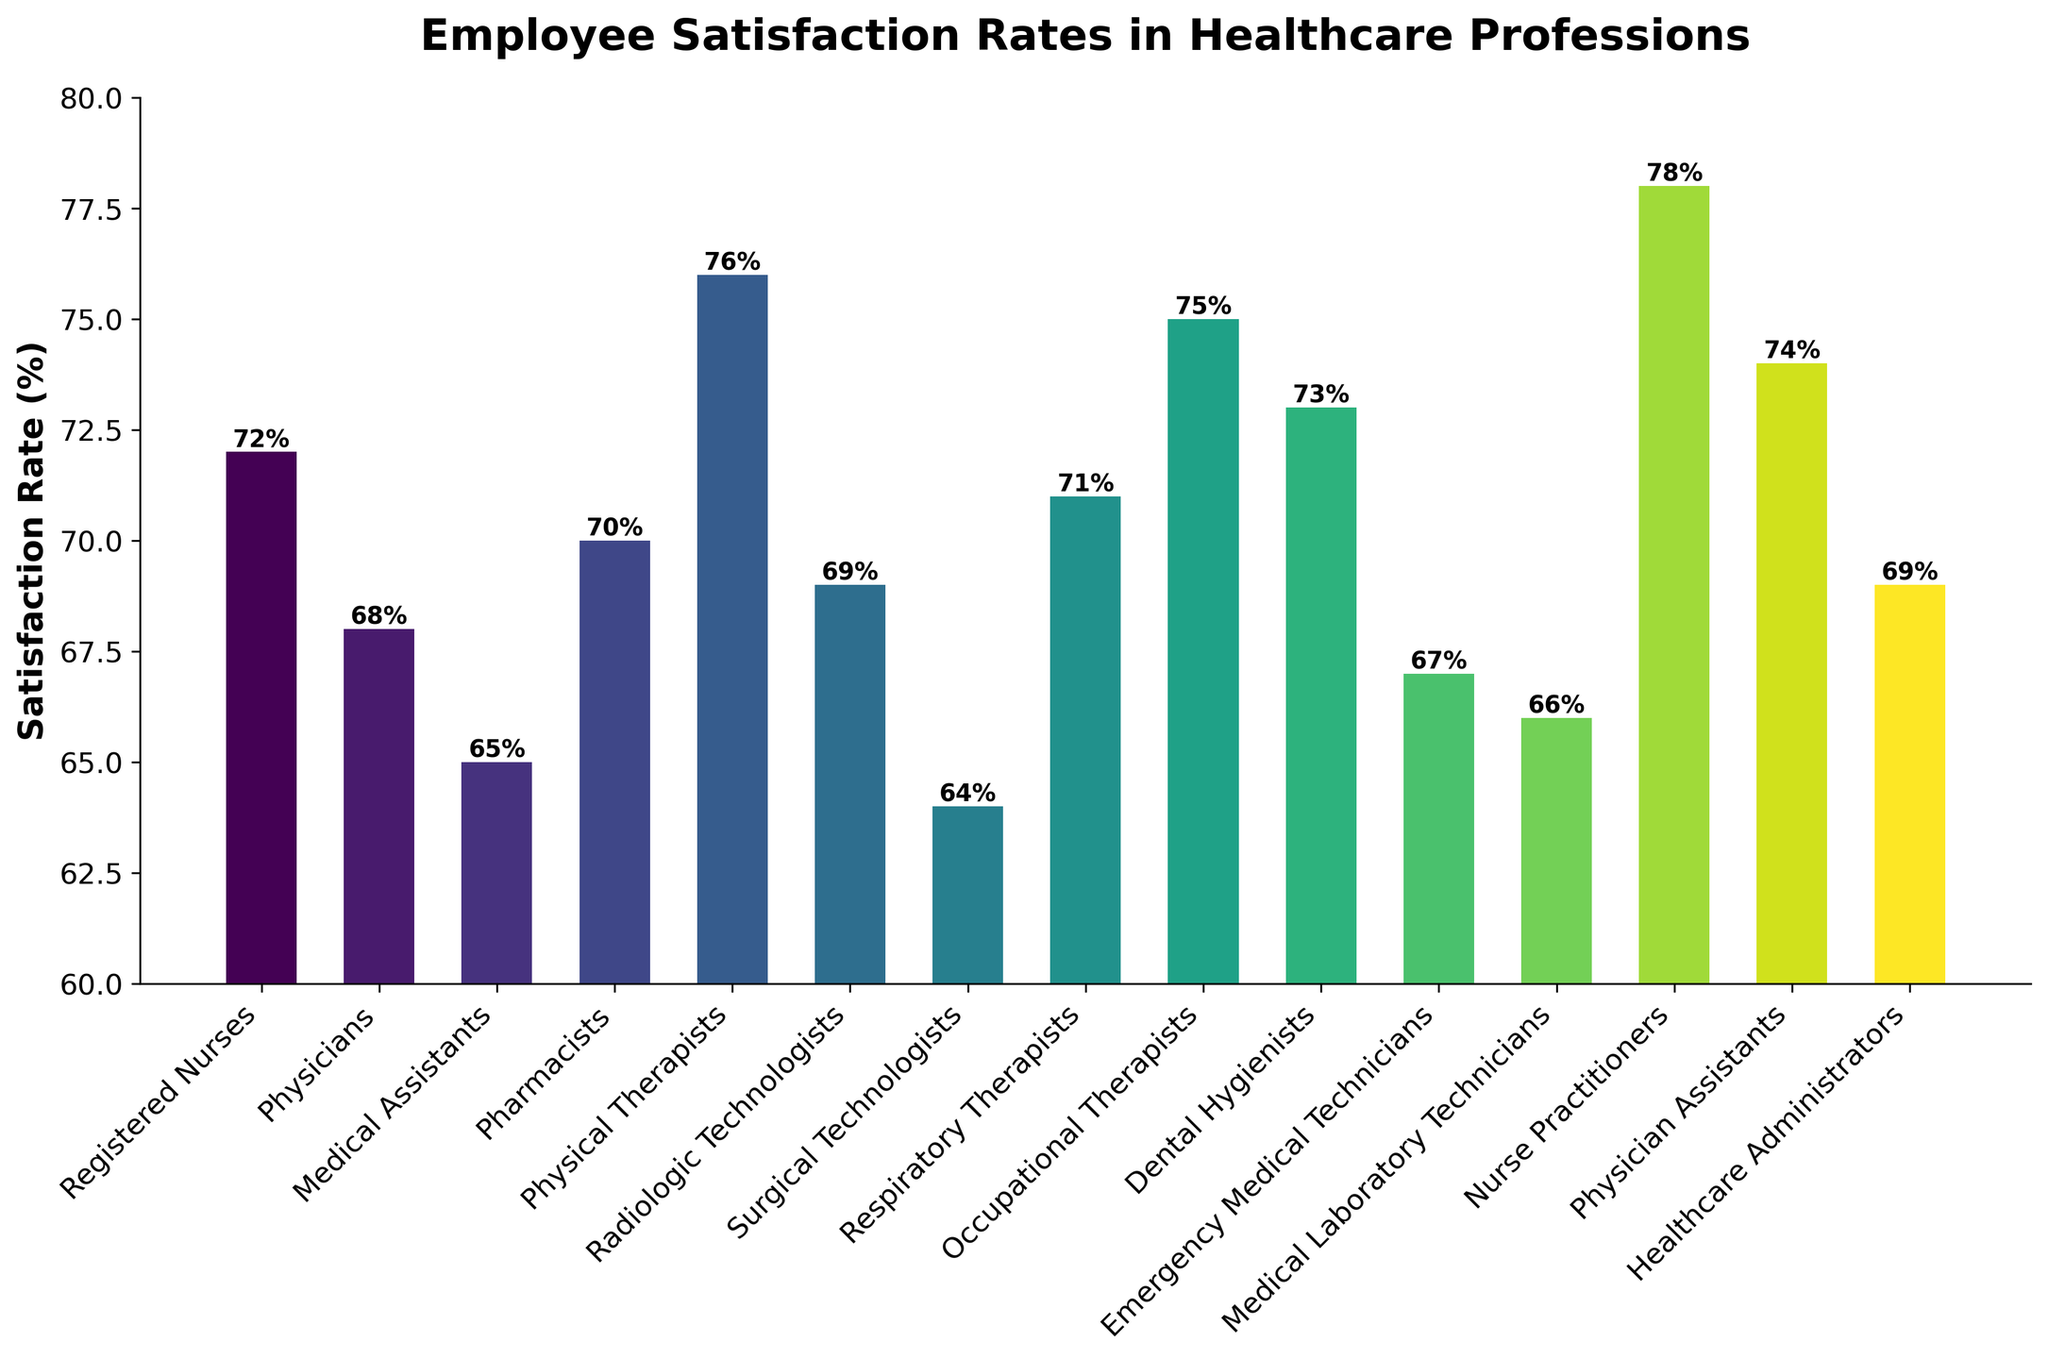Which profession has the highest satisfaction rate? By observing the heights of the bars, the highest bar represents Nurse Practitioners with a satisfaction rate of 78%.
Answer: Nurse Practitioners Which profession has the lowest satisfaction rate? By comparing the heights of the bars, the lowest bar represents Surgical Technologists with a satisfaction rate of 64%.
Answer: Surgical Technologists What is the average satisfaction rate of all professions shown in the chart? Add all the satisfaction rates and divide by the number of professions: (72 + 68 + 65 + 70 + 76 + 69 + 64 + 71 + 75 + 73 + 67 + 66 + 78 + 74 + 69) / 15 = 71.2
Answer: 71.2 Which profession has a satisfaction rate closest to 70%? By checking the satisfaction rates around 70%, Pharmacists have a satisfaction rate of 70%, which is exactly 70%.
Answer: Pharmacists How many professions have a satisfaction rate above 70%? Count the bars with heights above the 70% mark: Registered Nurses, Physical Therapists, Occupational Therapists, Dental Hygienists, Nurse Practitioners, Physician Assistants (6 professions).
Answer: 6 Which profession's satisfaction rate is exactly mid-way between the highest and the lowest satisfaction rates shown in the chart? The mid-way point between 78% (highest) and 64% (lowest) is (78 + 64) / 2 = 71%. The professions with satisfaction rates of 71% are Respiratory Therapists.
Answer: Respiratory Therapists Which satisfaction rates are within 1% of each other? Compare the heights of bars, considering a 1% difference: Registered Nurses (72%) and Dental Hygienists (73%), Healthcare Administrators (69%) and Radiologic Technologists (69%).
Answer: Registered Nurses and Dental Hygienists, Healthcare Administrators and Radiologic Technologists Which two professions have a combined satisfaction rate greater than 140%? Find two professions that add up to more than 140%: Physical Therapists (76%) and Medical Assistants (65%) = 76 + 65 = 141%.
Answer: Physical Therapists and Medical Assistants What is the difference in satisfaction rates between the highest and lowest rated professions? Subtract the lowest satisfaction rate from the highest: 78% - 64% = 14%.
Answer: 14% 